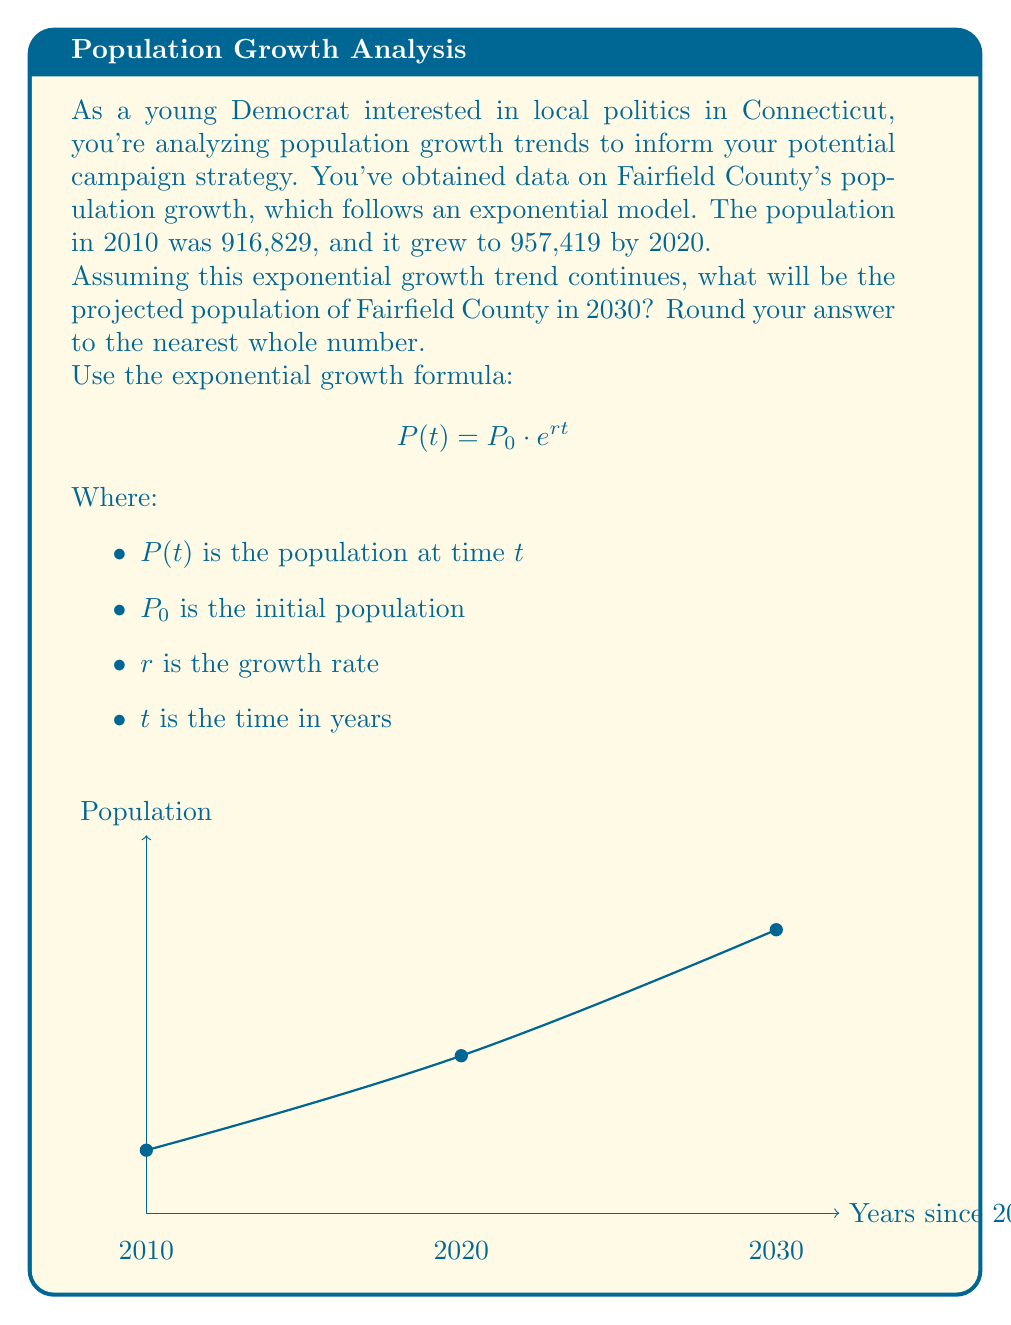Help me with this question. Let's solve this step-by-step:

1) We have two known points:
   2010: $P_0 = 916,829$
   2020: $P(10) = 957,419$

2) We can use these to find the growth rate $r$ using the exponential growth formula:

   $957,419 = 916,829 \cdot e^{10r}$

3) Divide both sides by 916,829:

   $1.0442 = e^{10r}$

4) Take the natural log of both sides:

   $\ln(1.0442) = 10r$

5) Solve for $r$:

   $r = \frac{\ln(1.0442)}{10} \approx 0.004387$

6) Now that we have $r$, we can project the population for 2030. This is 20 years from our initial point, so $t = 20$:

   $P(20) = 916,829 \cdot e^{0.004387 \cdot 20}$

7) Calculate:

   $P(20) = 916,829 \cdot e^{0.08774} \approx 999,942.7$

8) Rounding to the nearest whole number:

   $P(20) \approx 999,943$
Answer: 999,943 